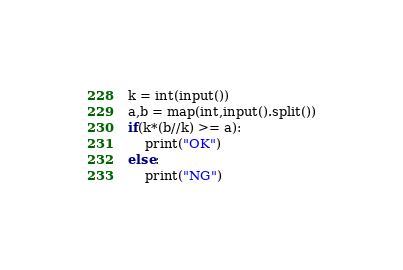<code> <loc_0><loc_0><loc_500><loc_500><_Python_>k = int(input())
a,b = map(int,input().split())
if(k*(b//k) >= a):
    print("OK")
else:
    print("NG")
</code> 